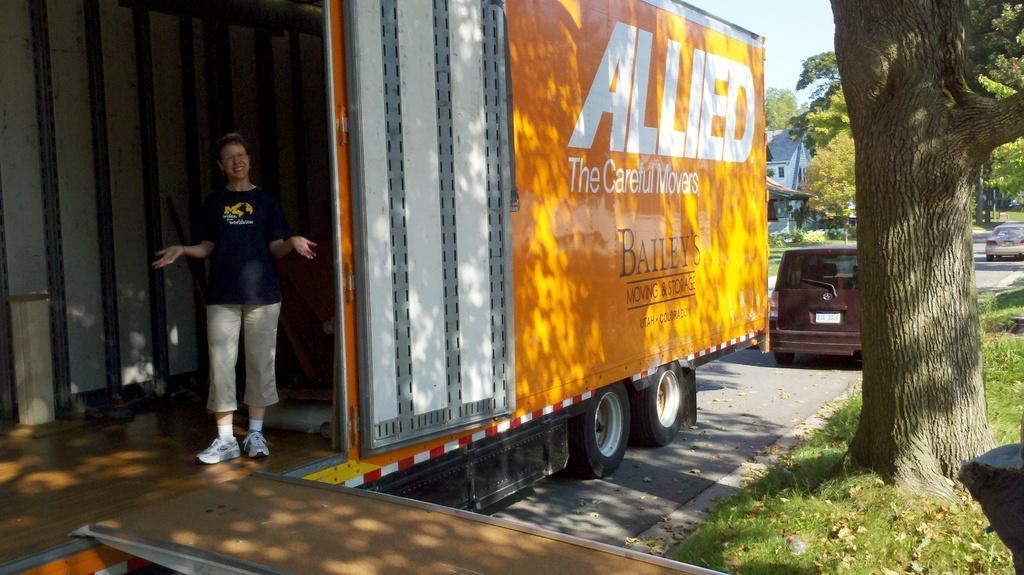Please provide a concise description of this image. In this image, there are a few vehicles, trees, plants and a house. We can see the ground with some grass. We can also see a person and some object on the right. We can also see the sky. 